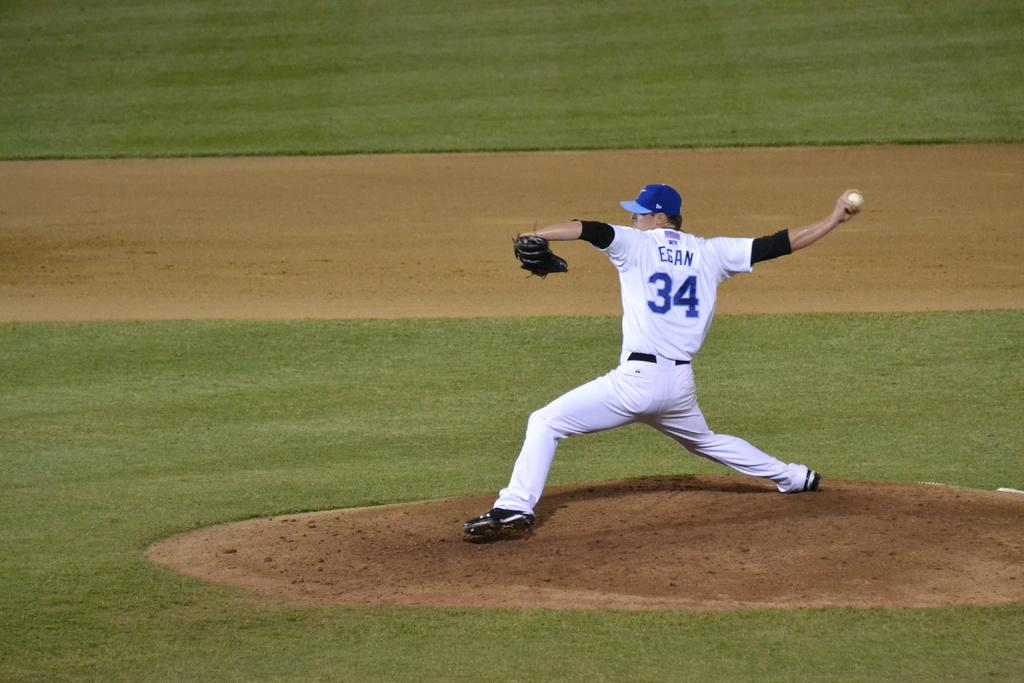What is the man in the image doing? The man is standing in the image and holding a ball. What is the man wearing on his head? The man is wearing a cap. What type of clothing is the man wearing on his upper body? The man is wearing a T-shirt. What type of clothing is the man wearing on his lower body? The man is wearing trousers. What type of footwear is the man wearing? The man is wearing shoes. What additional accessory is the man wearing? The man is wearing a baseball glove. What is the setting of the image? The setting appears to be a ground. What scientific experiment is being conducted in the image? There is no scientific experiment being conducted in the image; it features a man standing on a ground while holding a ball and wearing a baseball glove. 